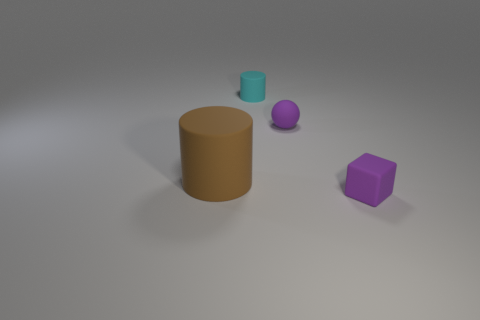What material is the object that is to the left of the purple matte ball and behind the brown matte cylinder? The material of the object, which appears as a small teal cylinder to the left of the purple ball and behind the large brown cylinder, looks like it could be made of plastic, given its smooth surface and light reflections that suggest a non-metallic, synthetic substance. 